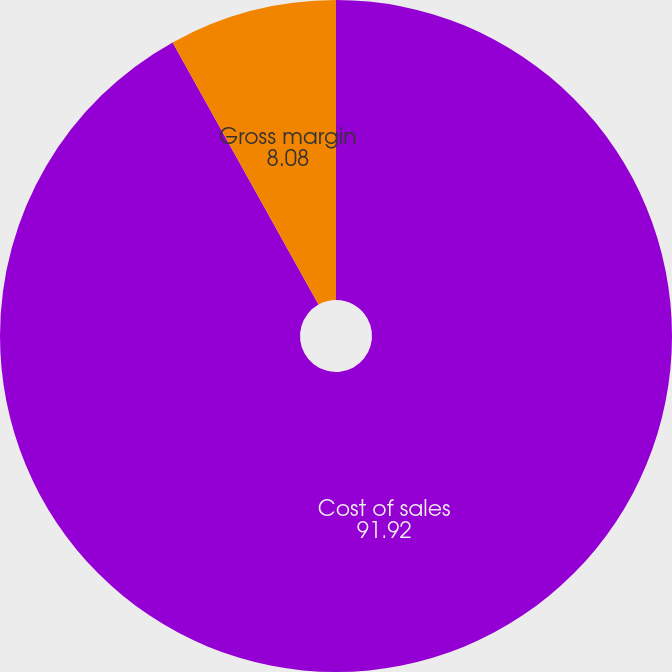Convert chart to OTSL. <chart><loc_0><loc_0><loc_500><loc_500><pie_chart><fcel>Cost of sales<fcel>Gross margin<nl><fcel>91.92%<fcel>8.08%<nl></chart> 